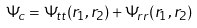Convert formula to latex. <formula><loc_0><loc_0><loc_500><loc_500>\Psi _ { c } = \Psi _ { t t } ( r _ { 1 } , r _ { 2 } ) + \Psi _ { r r } ( r _ { 1 } , r _ { 2 } )</formula> 